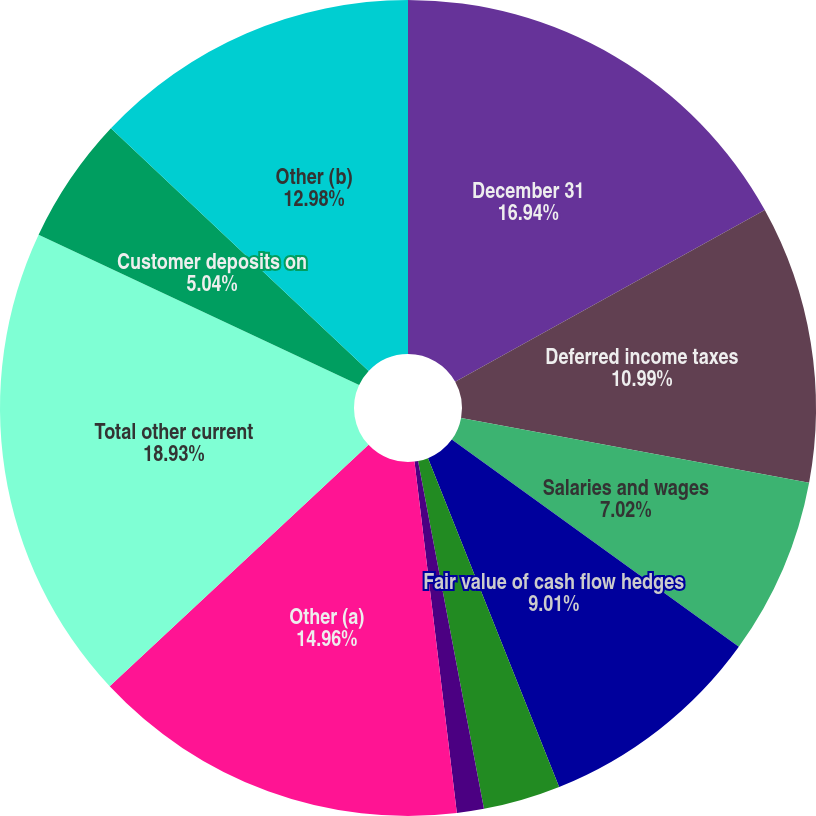Convert chart to OTSL. <chart><loc_0><loc_0><loc_500><loc_500><pie_chart><fcel>December 31<fcel>Deferred income taxes<fcel>Salaries and wages<fcel>Fair value of cash flow hedges<fcel>Workers' compensation<fcel>Retirement benefits<fcel>Other (a)<fcel>Total other current<fcel>Customer deposits on<fcel>Other (b)<nl><fcel>16.94%<fcel>10.99%<fcel>7.02%<fcel>9.01%<fcel>3.06%<fcel>1.07%<fcel>14.96%<fcel>18.93%<fcel>5.04%<fcel>12.98%<nl></chart> 